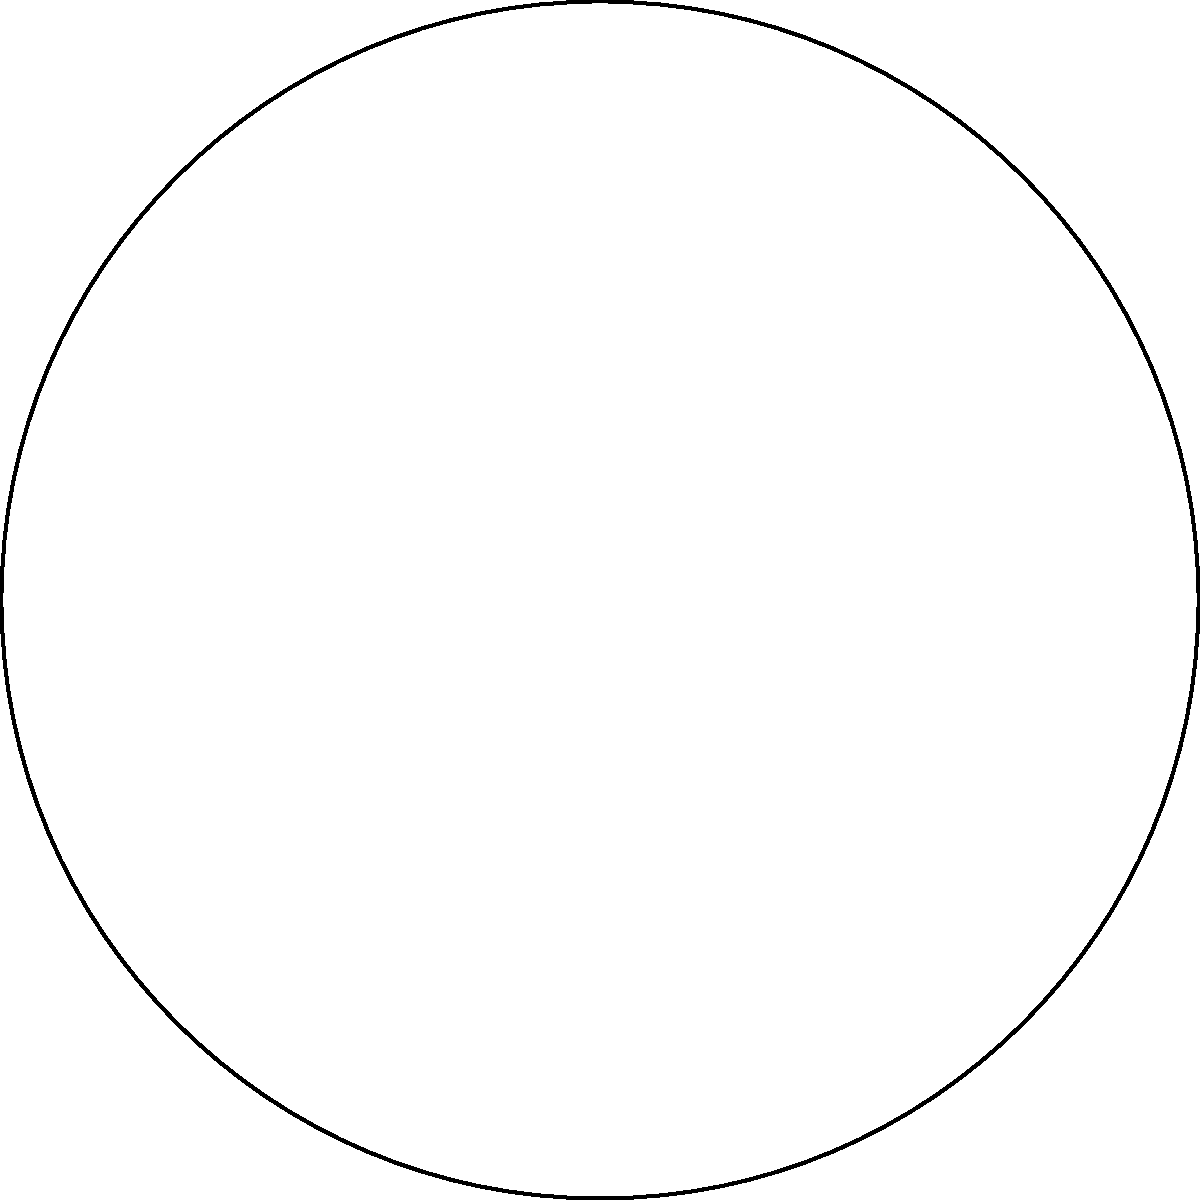As a mystery shopper, you're tasked with evaluating a circular food court within a square shopping center. The shopping center measures 80 feet on each side, and the radius of the food court is exactly half the length of the shopping center's side. What is the area of the food court in square feet? Let's approach this step-by-step:

1) First, we need to determine the side length of the shopping center:
   Side length = 80 feet

2) The radius of the food court is half the side length:
   $r = \frac{80}{2} = 40$ feet

3) To calculate the area of a circle, we use the formula:
   $A = \pi r^2$

4) Substituting our radius value:
   $A = \pi (40)^2$
   $A = \pi (1600)$
   $A = 1600\pi$ square feet

5) If we want to calculate the exact value:
   $A \approx 5026.55$ square feet (rounded to two decimal places)

As a mystery shopper, you might need to report the exact formula (1600π) or the approximate value, depending on the instructions given for the assignment.
Answer: $1600\pi$ square feet 